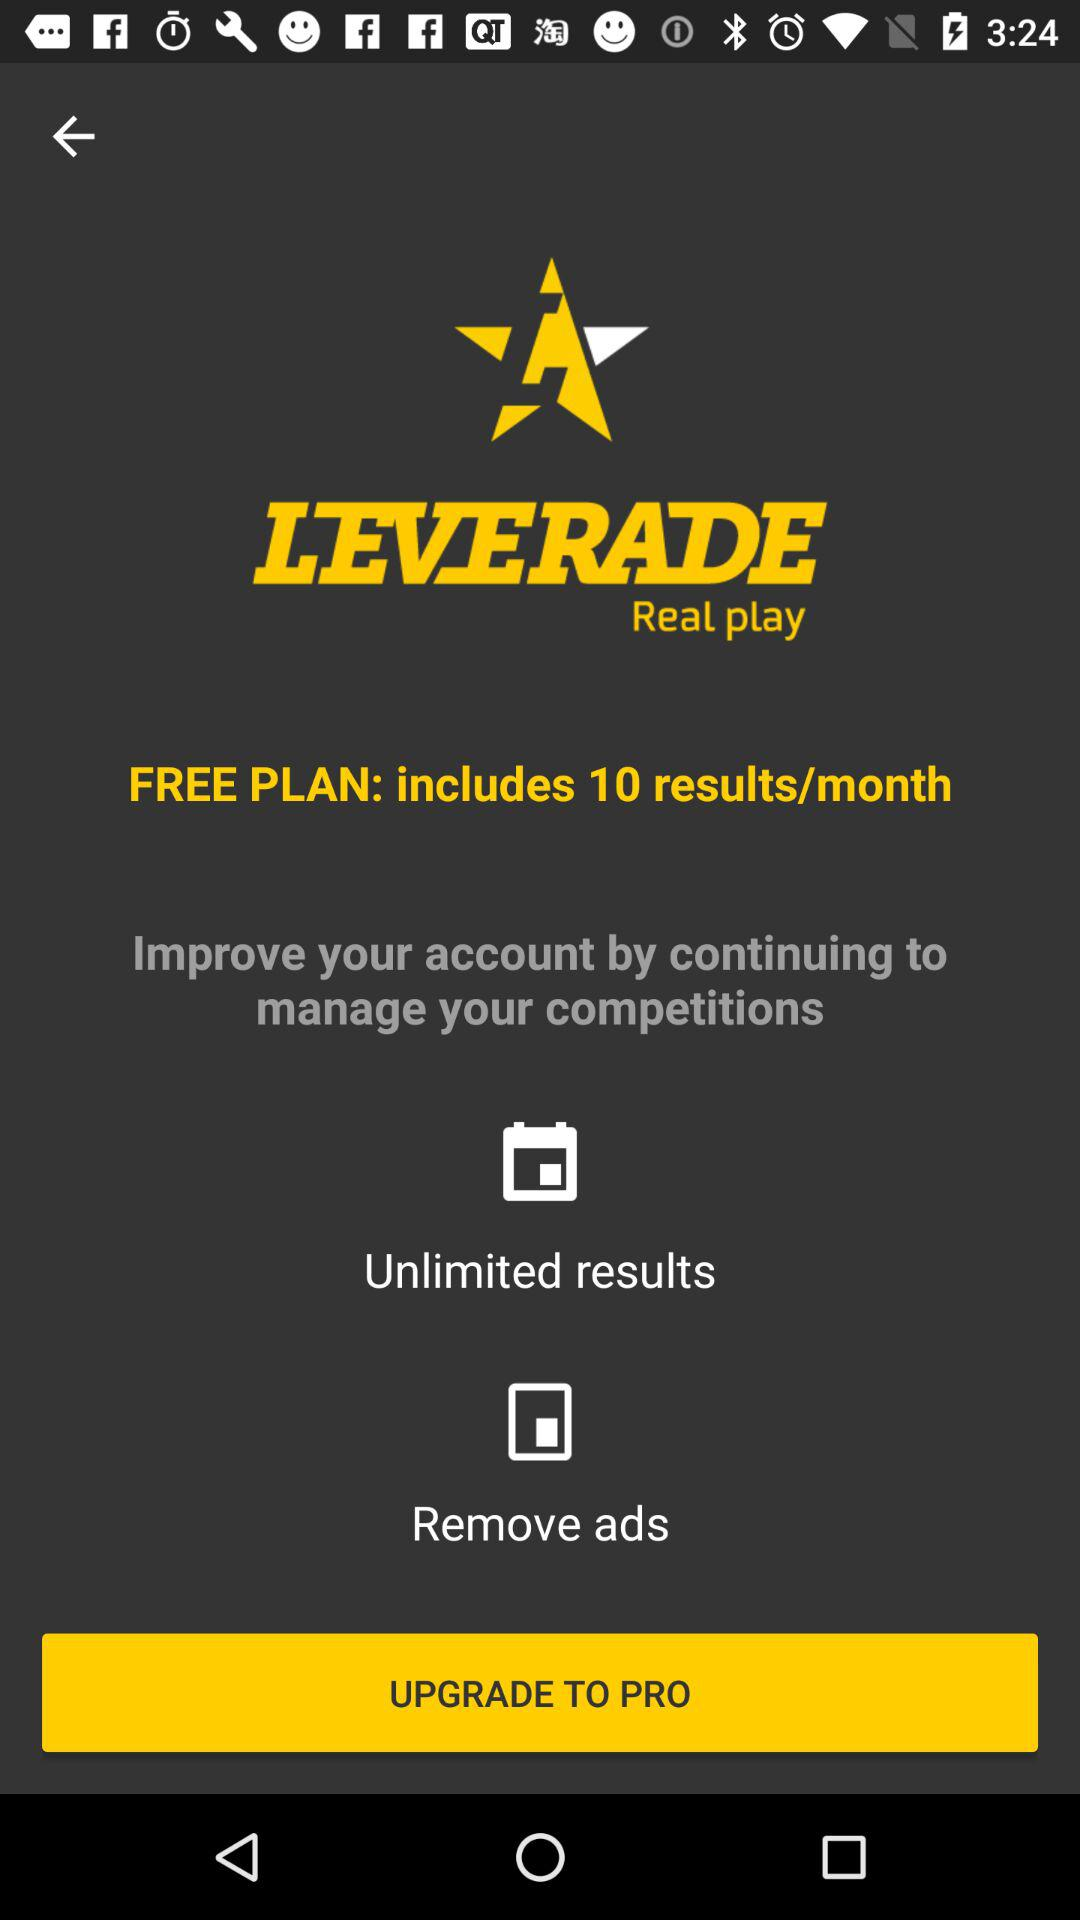What does a free plan include? A free plan includes 10 results/month. 